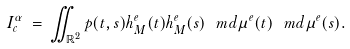<formula> <loc_0><loc_0><loc_500><loc_500>I _ { c } ^ { \alpha } \, = \, \iint _ { \mathbb { R } ^ { 2 } } p ( t , s ) h _ { M } ^ { e } ( t ) h _ { M } ^ { e } ( s ) \, \ m d \mu ^ { e } ( t ) \, \ m d \mu ^ { e } ( s ) .</formula> 